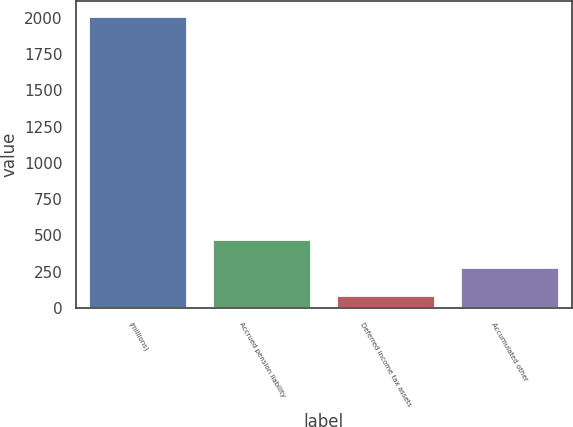<chart> <loc_0><loc_0><loc_500><loc_500><bar_chart><fcel>(millions)<fcel>Accrued pension liability<fcel>Deferred income tax assets<fcel>Accumulated other<nl><fcel>2016<fcel>475.92<fcel>90.9<fcel>283.41<nl></chart> 